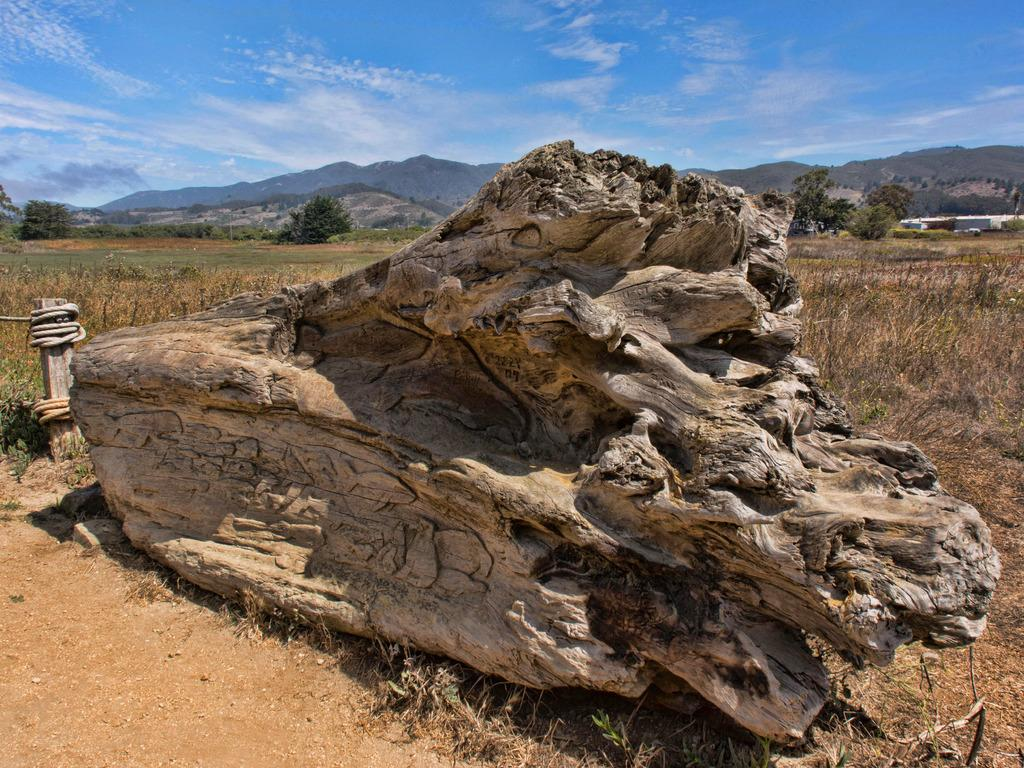What type of wooden object can be seen in the image? There is a wooden object in the image, but its specific type is not mentioned. What other objects are present in the image? There is a pole, ropes, and grass visible in the image. What can be seen in the background of the image? There are trees, hills, and the sky visible in the background of the image. How many robins are perched on the wooden object in the image? There are no robins present in the image. What type of clouds can be seen in the sky in the image? The provided facts do not mention any clouds in the sky, only that the sky is visible in the background of the image. 